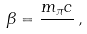<formula> <loc_0><loc_0><loc_500><loc_500>\beta = { \frac { m _ { \pi } c } { } } \, ,</formula> 